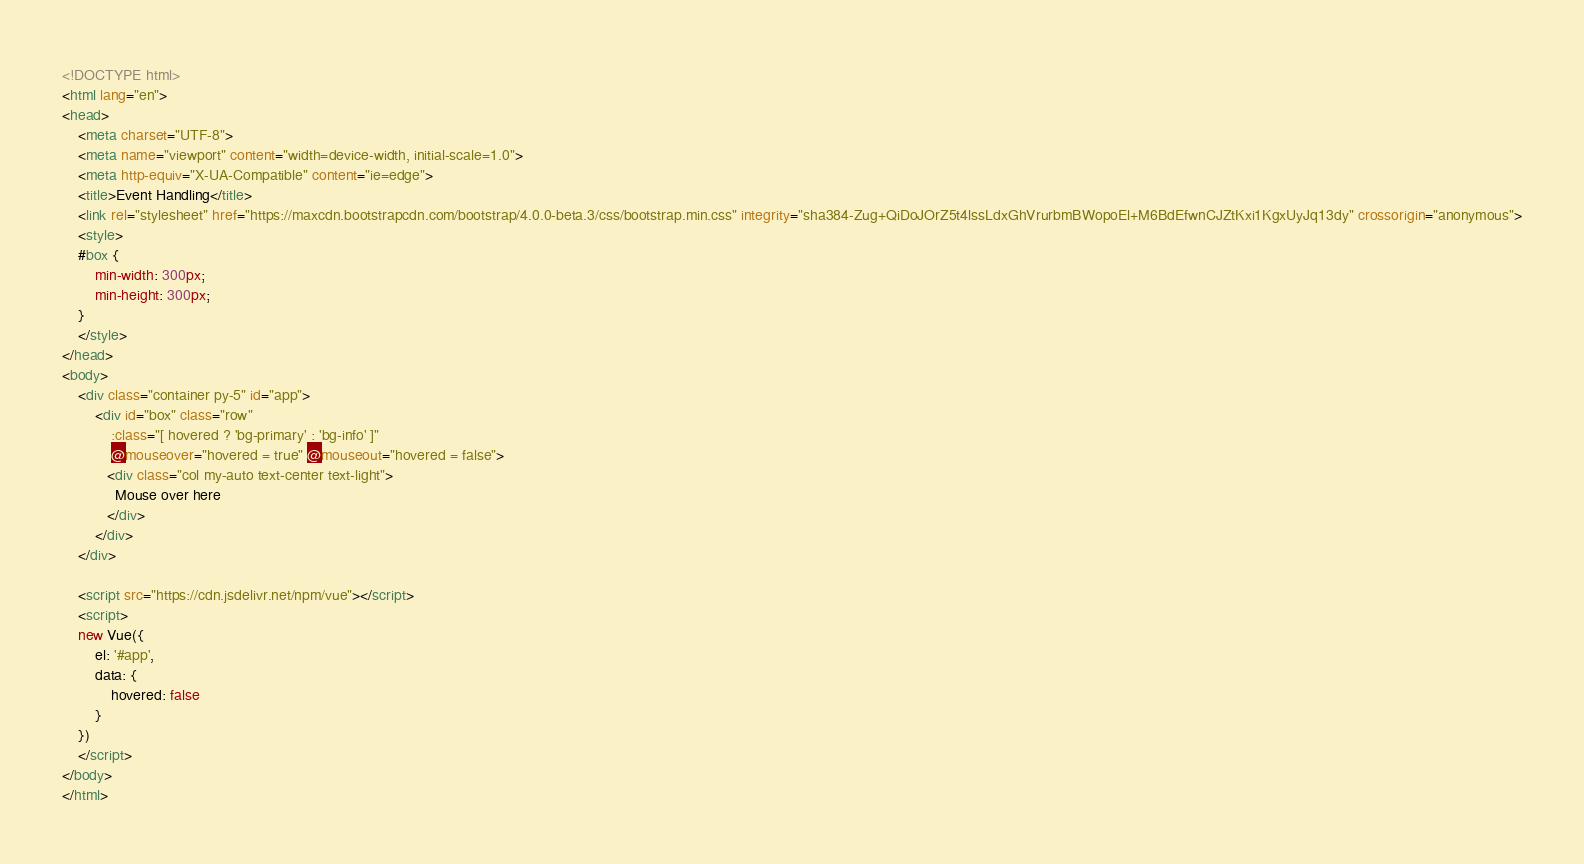Convert code to text. <code><loc_0><loc_0><loc_500><loc_500><_HTML_><!DOCTYPE html>
<html lang="en">
<head>
    <meta charset="UTF-8">
    <meta name="viewport" content="width=device-width, initial-scale=1.0">
    <meta http-equiv="X-UA-Compatible" content="ie=edge">
    <title>Event Handling</title>
    <link rel="stylesheet" href="https://maxcdn.bootstrapcdn.com/bootstrap/4.0.0-beta.3/css/bootstrap.min.css" integrity="sha384-Zug+QiDoJOrZ5t4lssLdxGhVrurbmBWopoEl+M6BdEfwnCJZtKxi1KgxUyJq13dy" crossorigin="anonymous">
    <style>
    #box {
        min-width: 300px;
        min-height: 300px;
    }
    </style>
</head>
<body>
    <div class="container py-5" id="app">
        <div id="box" class="row"
            :class="[ hovered ? 'bg-primary' : 'bg-info' ]"
            @mouseover="hovered = true" @mouseout="hovered = false">
           <div class="col my-auto text-center text-light">
             Mouse over here
           </div>
        </div>
    </div>

    <script src="https://cdn.jsdelivr.net/npm/vue"></script>
    <script>
    new Vue({
        el: '#app',
        data: {
            hovered: false
        }
    })
    </script>
</body>
</html>
</code> 